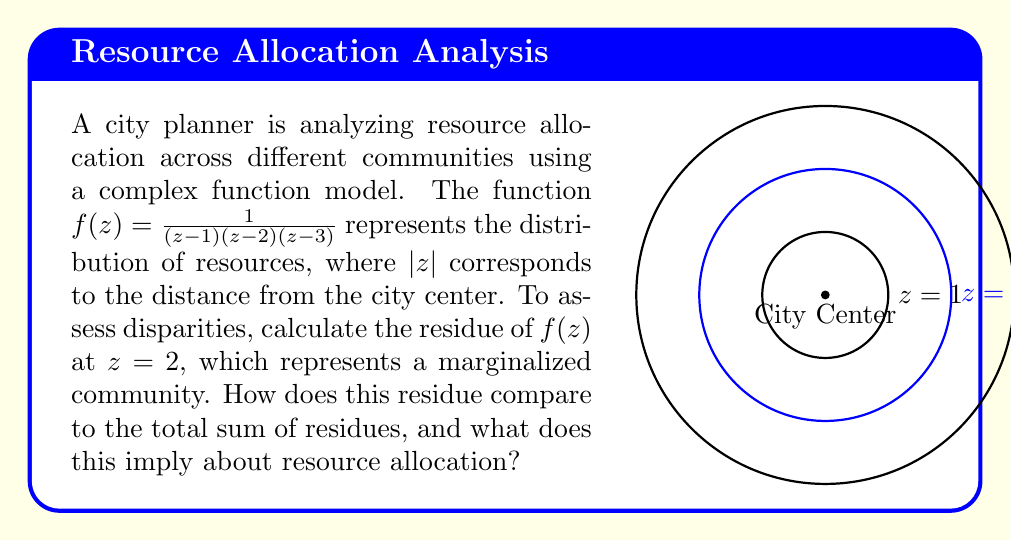Help me with this question. To solve this problem, we'll follow these steps:

1) The residue of $f(z)$ at $z=2$ can be calculated using the formula:
   $$\text{Res}(f,2) = \lim_{z \to 2} (z-2)f(z)$$

2) Substituting $f(z)$:
   $$\text{Res}(f,2) = \lim_{z \to 2} \frac{z-2}{(z-1)(z-2)(z-3)}$$

3) The $(z-2)$ terms cancel out:
   $$\text{Res}(f,2) = \lim_{z \to 2} \frac{1}{(z-1)(z-3)}$$

4) Evaluating the limit:
   $$\text{Res}(f,2) = \frac{1}{(2-1)(2-3)} = \frac{1}{1(-1)} = -1$$

5) To find the total sum of residues, we can use the residue theorem:
   $$\sum \text{Res}(f,z_k) = \frac{1}{2\pi i} \oint_C f(z)dz = 0$$
   
   This is because $f(z)$ is analytic at infinity, so the sum of all residues must be zero.

6) We have three poles at $z=1$, $z=2$, and $z=3$. Let's call their residues $R_1$, $R_2$, and $R_3$ respectively.
   We know that $R_2 = -1$ and $R_1 + R_2 + R_3 = 0$.

7) The residue at $z=2$ ($R_2 = -1$) represents one-third of the total absolute sum of residues.

8) This implies that the marginalized community at $z=2$ is receiving a significant portion (one-third) of the total resources, which is equal in magnitude to each of the other communities.
Answer: Residue at $z=2$ is $-1$, representing one-third of total resources, indicating equal allocation to the marginalized community. 